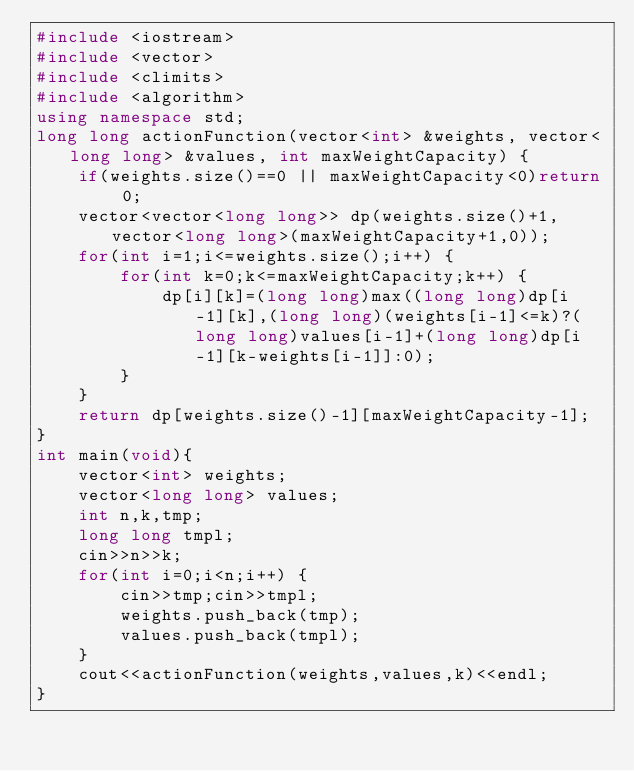<code> <loc_0><loc_0><loc_500><loc_500><_C++_>#include <iostream>
#include <vector>
#include <climits>
#include <algorithm>
using namespace std;
long long actionFunction(vector<int> &weights, vector<long long> &values, int maxWeightCapacity) {
    if(weights.size()==0 || maxWeightCapacity<0)return 0;
    vector<vector<long long>> dp(weights.size()+1,vector<long long>(maxWeightCapacity+1,0));
    for(int i=1;i<=weights.size();i++) {
        for(int k=0;k<=maxWeightCapacity;k++) {
            dp[i][k]=(long long)max((long long)dp[i-1][k],(long long)(weights[i-1]<=k)?(long long)values[i-1]+(long long)dp[i-1][k-weights[i-1]]:0);
        }
    }
    return dp[weights.size()-1][maxWeightCapacity-1];
}
int main(void){
    vector<int> weights;
    vector<long long> values;
    int n,k,tmp;
    long long tmpl;
    cin>>n>>k;
    for(int i=0;i<n;i++) {
        cin>>tmp;cin>>tmpl;
        weights.push_back(tmp);
        values.push_back(tmpl);
    }
    cout<<actionFunction(weights,values,k)<<endl;
}
</code> 